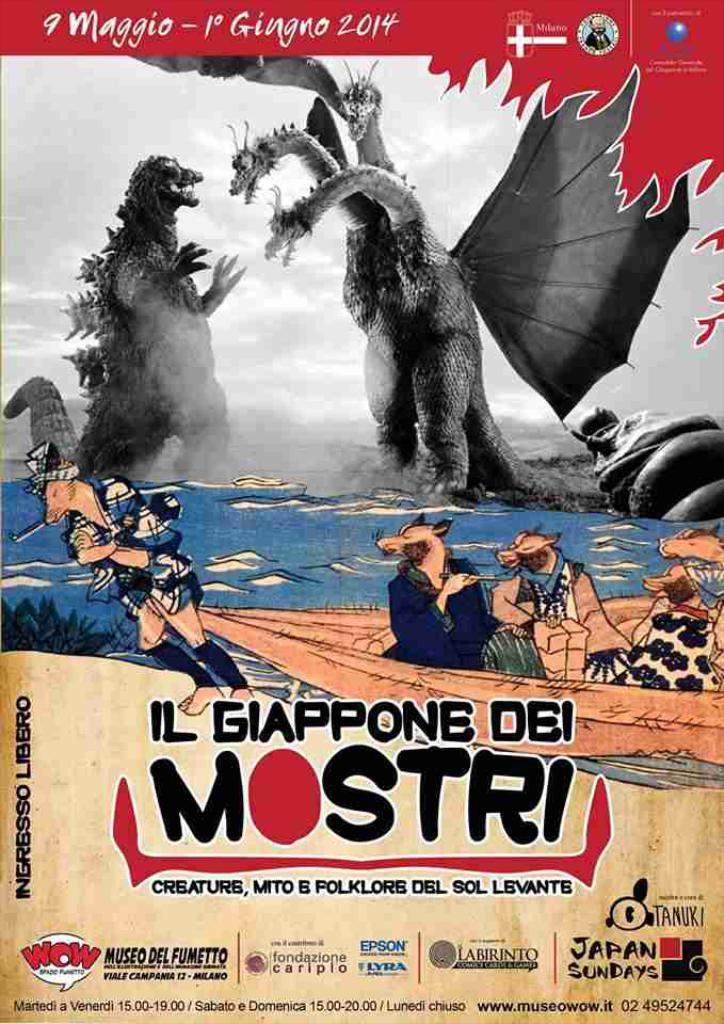What is featured on the poster in the image? The poster in the image has dragon images and cartoons. Where is the text located on the poster? There is text at the top and bottom of the image. What type of lock is used to secure the dragon on the poster? There is no lock present on the poster, as it features dragon images and cartoons. 